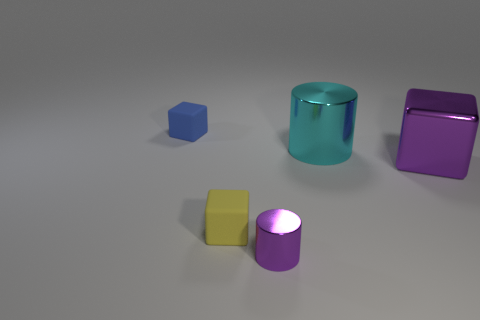There is a purple shiny thing to the right of the cylinder in front of the metallic cylinder that is behind the small purple metal thing; what is its size?
Your answer should be very brief. Large. What material is the yellow cube that is the same size as the purple cylinder?
Make the answer very short. Rubber. Are there any yellow cubes that have the same size as the yellow rubber thing?
Offer a very short reply. No. Do the cyan metal thing and the tiny blue matte thing have the same shape?
Make the answer very short. No. There is a cylinder that is behind the purple thing that is on the left side of the large cyan cylinder; is there a big cyan metallic object on the right side of it?
Keep it short and to the point. No. What number of other objects are there of the same color as the large shiny cylinder?
Offer a terse response. 0. Does the metallic cylinder to the right of the small shiny object have the same size as the metal object that is to the right of the big cyan metal cylinder?
Make the answer very short. Yes. Are there the same number of tiny purple cylinders that are in front of the purple cylinder and small cylinders right of the big metallic block?
Your answer should be compact. Yes. Are there any other things that are the same material as the purple cube?
Give a very brief answer. Yes. There is a cyan cylinder; is its size the same as the purple shiny object that is right of the tiny purple metallic object?
Make the answer very short. Yes. 